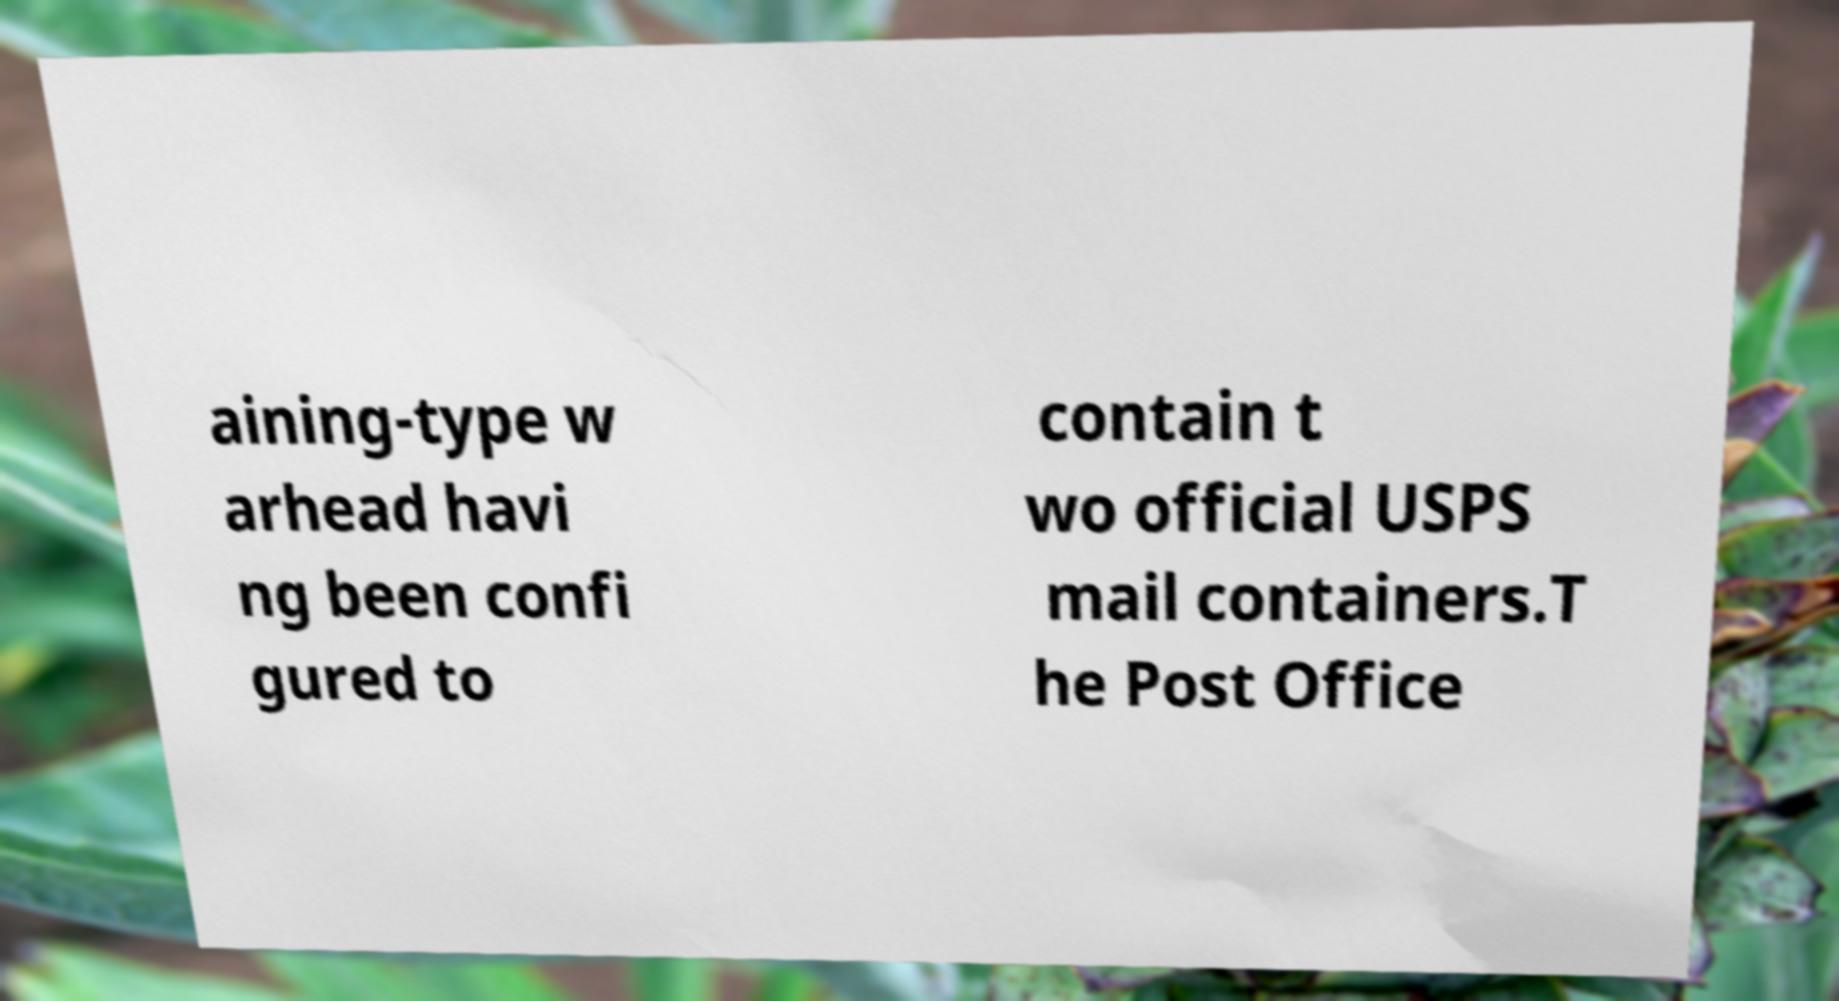Please identify and transcribe the text found in this image. aining-type w arhead havi ng been confi gured to contain t wo official USPS mail containers.T he Post Office 